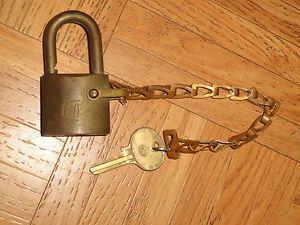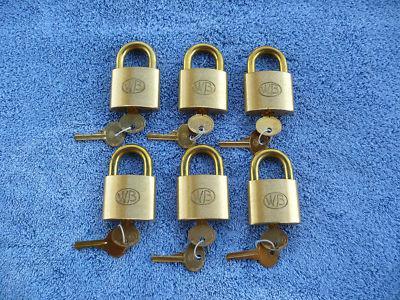The first image is the image on the left, the second image is the image on the right. Given the left and right images, does the statement "A key is in a single lock in the image on the left." hold true? Answer yes or no. No. 